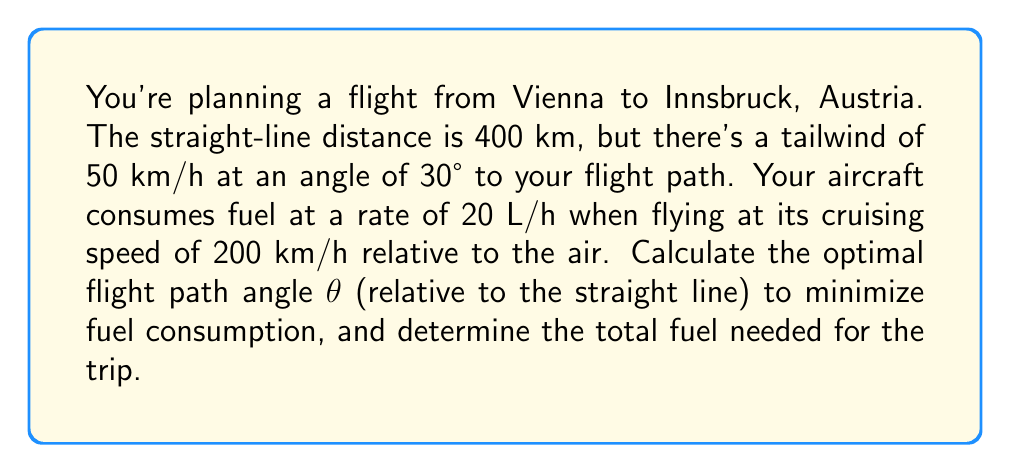What is the answer to this math problem? 1) First, let's set up our variables:
   - $d$ = 400 km (straight-line distance)
   - $v$ = 200 km/h (aircraft speed relative to air)
   - $w$ = 50 km/h (wind speed)
   - $\alpha$ = 30° (wind angle to straight path)
   - $\theta$ = optimal flight path angle (to be determined)
   - $f$ = 20 L/h (fuel consumption rate)

2) The ground speed of the aircraft can be expressed as:
   $$v_g = \sqrt{v^2 + w^2 + 2vw\cos(\alpha-\theta)}$$

3) The time of flight is:
   $$t = \frac{d}{\sqrt{v^2 + w^2 + 2vw\cos(\alpha-\theta)}}$$

4) Fuel consumption is proportional to time, so we need to minimize $t$.

5) To find the minimum, we differentiate $t$ with respect to $\theta$ and set it to zero:
   $$\frac{dt}{d\theta} = \frac{-d \cdot 2vw\sin(\alpha-\theta)}{2(v^2 + w^2 + 2vw\cos(\alpha-\theta))^{3/2}} = 0$$

6) This simplifies to:
   $$\sin(\alpha-\theta) = 0$$

7) The solution is:
   $$\alpha - \theta = 0$$
   $$\theta = \alpha = 30°$$

8) Now we can calculate the ground speed:
   $$v_g = \sqrt{200^2 + 50^2 + 2(200)(50)\cos(0)} = 250 \text{ km/h}$$

9) The flight time is:
   $$t = \frac{400}{250} = 1.6 \text{ hours}$$

10) The total fuel consumed is:
    $$\text{Fuel} = 20 \text{ L/h} \times 1.6 \text{ h} = 32 \text{ L}$$
Answer: $\theta = 30°$, 32 L 